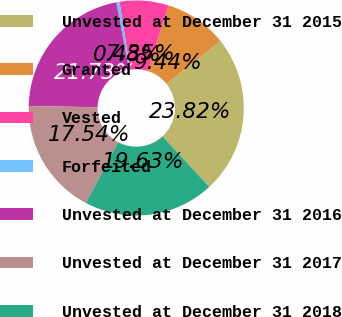<chart> <loc_0><loc_0><loc_500><loc_500><pie_chart><fcel>Unvested at December 31 2015<fcel>Granted<fcel>Vested<fcel>Forfeited<fcel>Unvested at December 31 2016<fcel>Unvested at December 31 2017<fcel>Unvested at December 31 2018<nl><fcel>23.82%<fcel>9.44%<fcel>7.35%<fcel>0.48%<fcel>21.73%<fcel>17.54%<fcel>19.63%<nl></chart> 